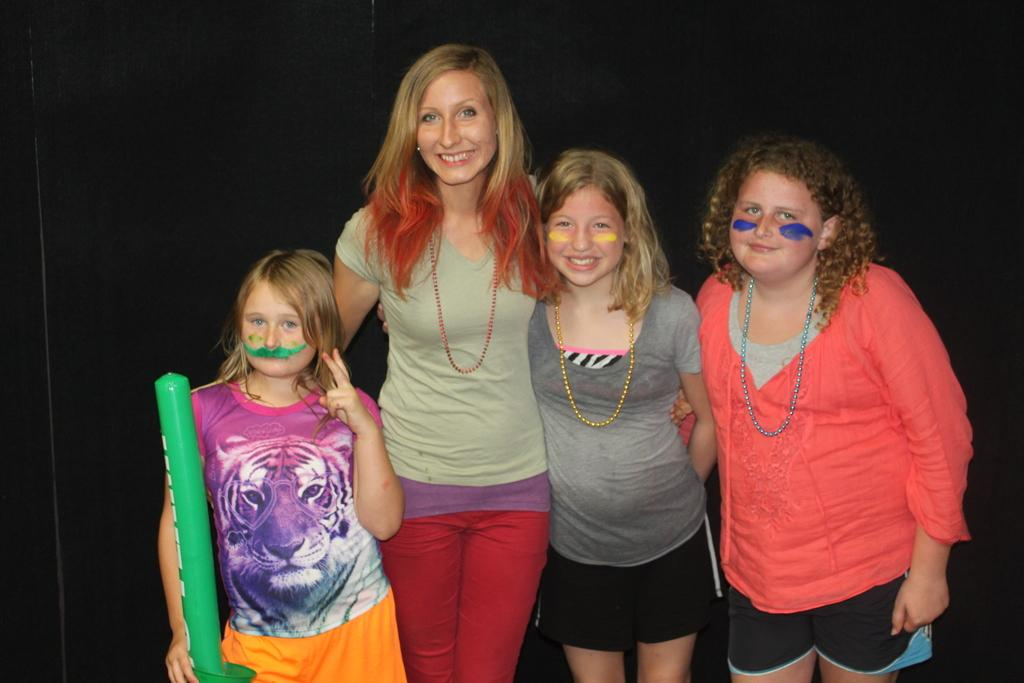How many people are in the image? There are four persons in the image. What are the persons in the image doing? The persons are standing in the image. What expressions do the persons have? The persons are smiling in the image. What is the color of the background in the image? The background of the image is dark. What type of invention can be seen in the hands of the persons in the image? There is no invention visible in the hands of the persons in the image. What type of punishment is being carried out on the persons in the image? There is no punishment being carried out on the persons in the image; they are standing and smiling. 